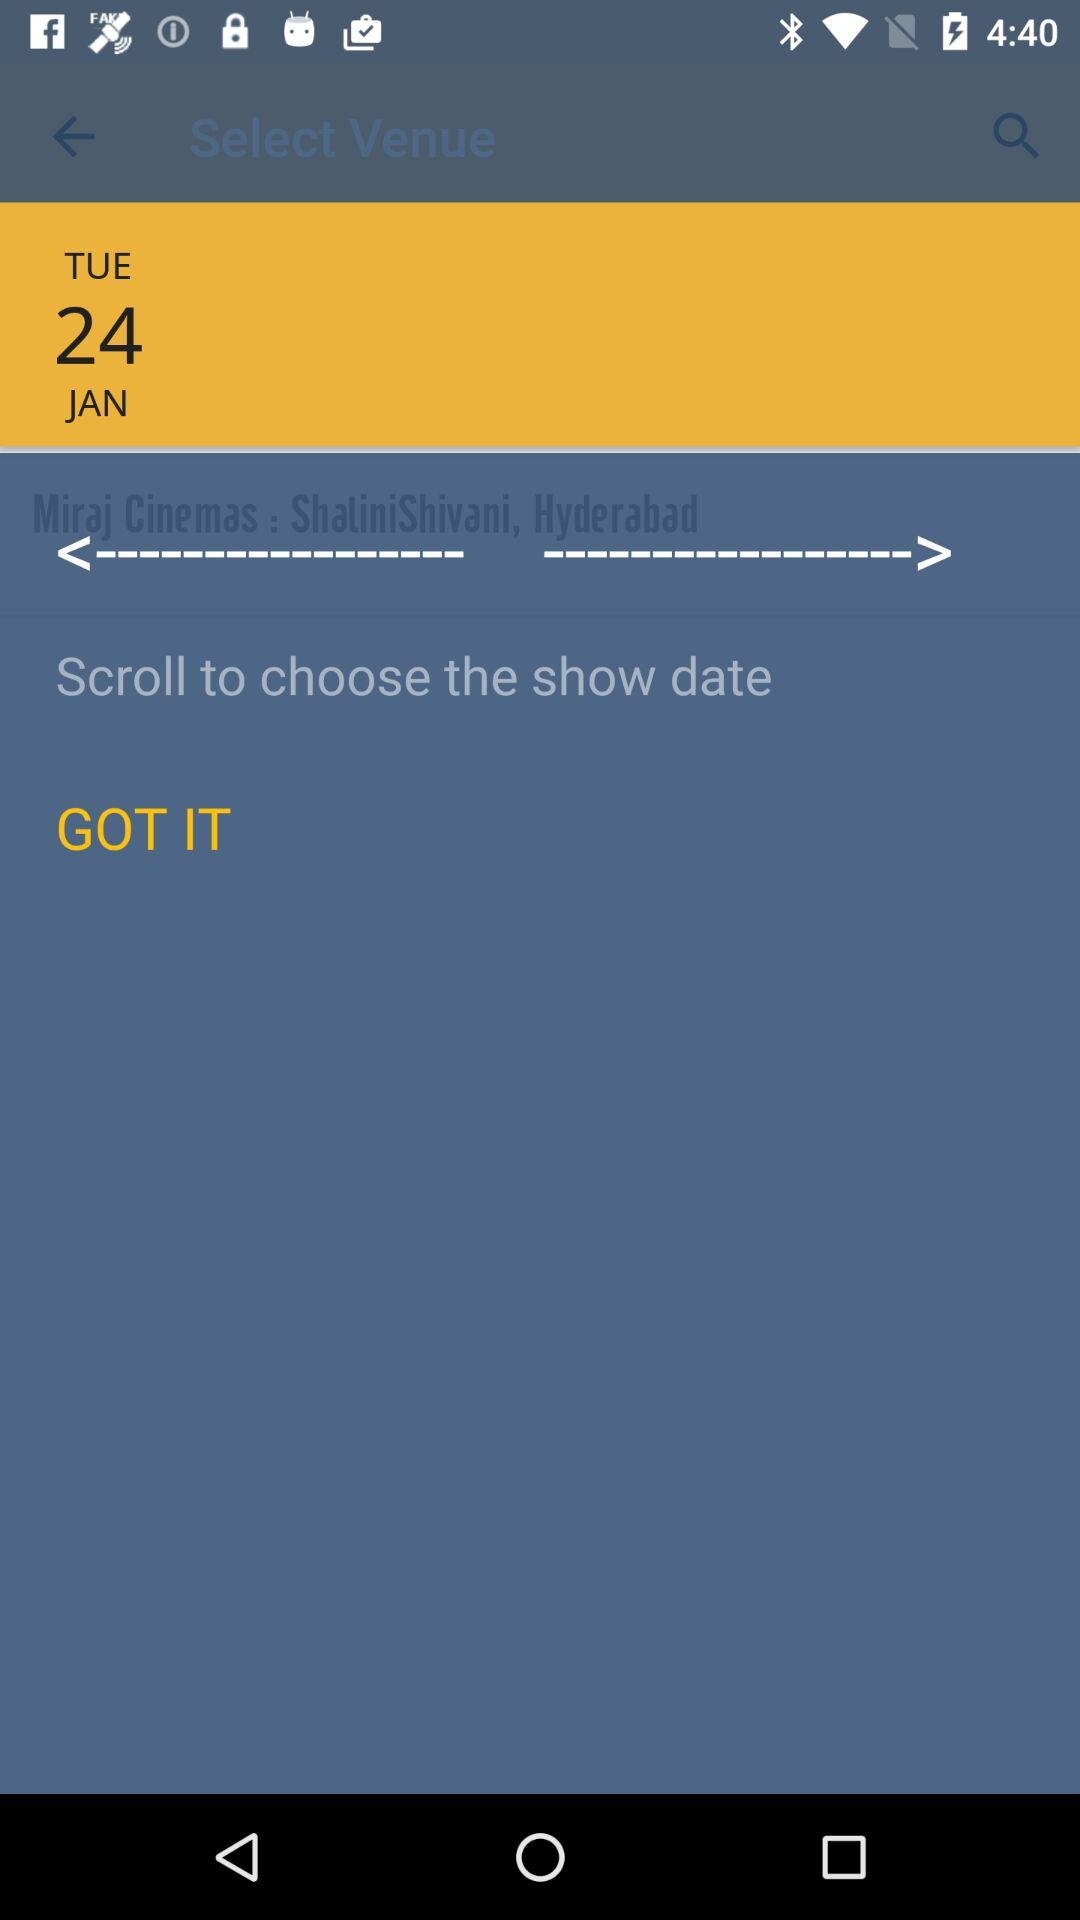What day falls on January 24th? The day is Tuesday. 